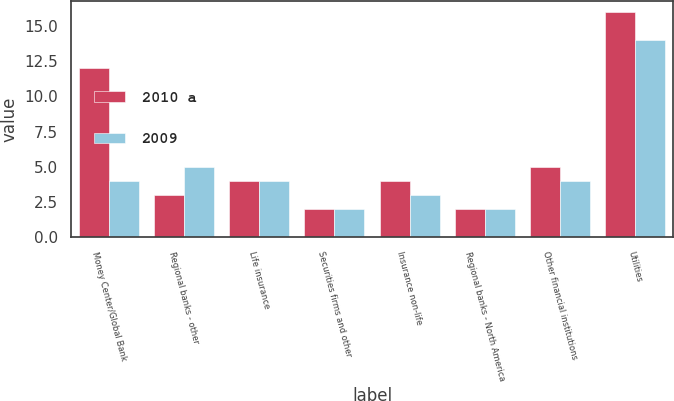<chart> <loc_0><loc_0><loc_500><loc_500><stacked_bar_chart><ecel><fcel>Money Center/Global Bank<fcel>Regional banks - other<fcel>Life insurance<fcel>Securities firms and other<fcel>Insurance non-life<fcel>Regional banks - North America<fcel>Other financial institutions<fcel>Utilities<nl><fcel>2010 a<fcel>12<fcel>3<fcel>4<fcel>2<fcel>4<fcel>2<fcel>5<fcel>16<nl><fcel>2009<fcel>4<fcel>5<fcel>4<fcel>2<fcel>3<fcel>2<fcel>4<fcel>14<nl></chart> 